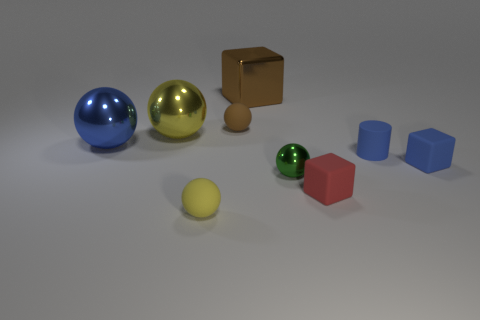There is a big thing that is the same color as the tiny rubber cylinder; what is its shape?
Make the answer very short. Sphere. There is a big block; is it the same color as the small ball that is behind the green object?
Your answer should be compact. Yes. What is the big yellow ball made of?
Provide a succinct answer. Metal. There is a object that is behind the small matte ball that is behind the yellow object behind the big blue object; what is its shape?
Your answer should be very brief. Cube. The small brown object that is made of the same material as the small blue block is what shape?
Your answer should be compact. Sphere. How big is the shiny block?
Offer a very short reply. Large. Does the blue metallic object have the same size as the brown block?
Offer a very short reply. Yes. What number of things are small blue rubber objects that are behind the small blue cube or matte objects on the right side of the yellow rubber object?
Offer a terse response. 4. There is a big metal thing in front of the yellow thing left of the small yellow sphere; what number of tiny red things are left of it?
Your answer should be very brief. 0. How big is the yellow sphere that is behind the yellow rubber ball?
Offer a very short reply. Large. 